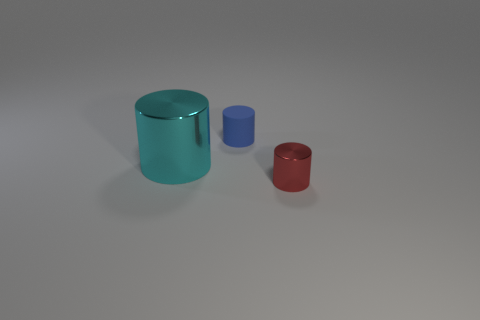What number of objects are both in front of the small blue object and on the left side of the red metal object?
Offer a very short reply. 1. What material is the tiny blue cylinder?
Your answer should be very brief. Rubber. Is the number of big things that are on the right side of the cyan object the same as the number of cyan things?
Your response must be concise. No. What number of small cyan objects have the same shape as the small red thing?
Offer a terse response. 0. Is the shape of the small matte object the same as the cyan thing?
Offer a very short reply. Yes. What number of objects are either small things that are behind the tiny red metallic cylinder or big cyan metal things?
Ensure brevity in your answer.  2. What is the shape of the small object that is left of the tiny cylinder in front of the metallic thing behind the small red object?
Ensure brevity in your answer.  Cylinder. There is a red object that is the same material as the cyan cylinder; what is its shape?
Provide a short and direct response. Cylinder. How big is the cyan cylinder?
Make the answer very short. Large. Is the red cylinder the same size as the blue rubber cylinder?
Provide a short and direct response. Yes. 